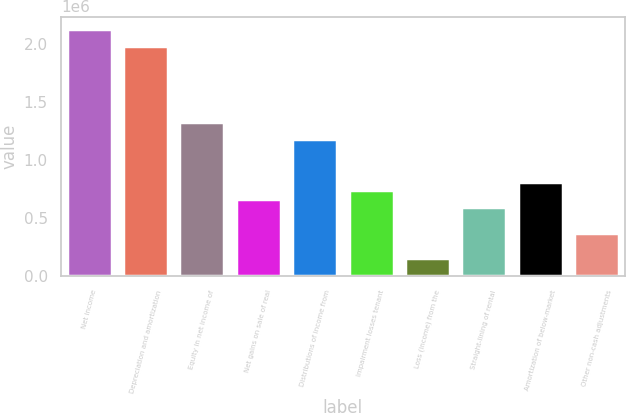Convert chart. <chart><loc_0><loc_0><loc_500><loc_500><bar_chart><fcel>Net income<fcel>Depreciation and amortization<fcel>Equity in net income of<fcel>Net gains on sale of real<fcel>Distributions of income from<fcel>Impairment losses tenant<fcel>Loss (income) from the<fcel>Straight-lining of rental<fcel>Amortization of below-market<fcel>Other non-cash adjustments<nl><fcel>2.13122e+06<fcel>1.98478e+06<fcel>1.32578e+06<fcel>666778<fcel>1.17933e+06<fcel>740000<fcel>154223<fcel>593556<fcel>813222<fcel>373890<nl></chart> 